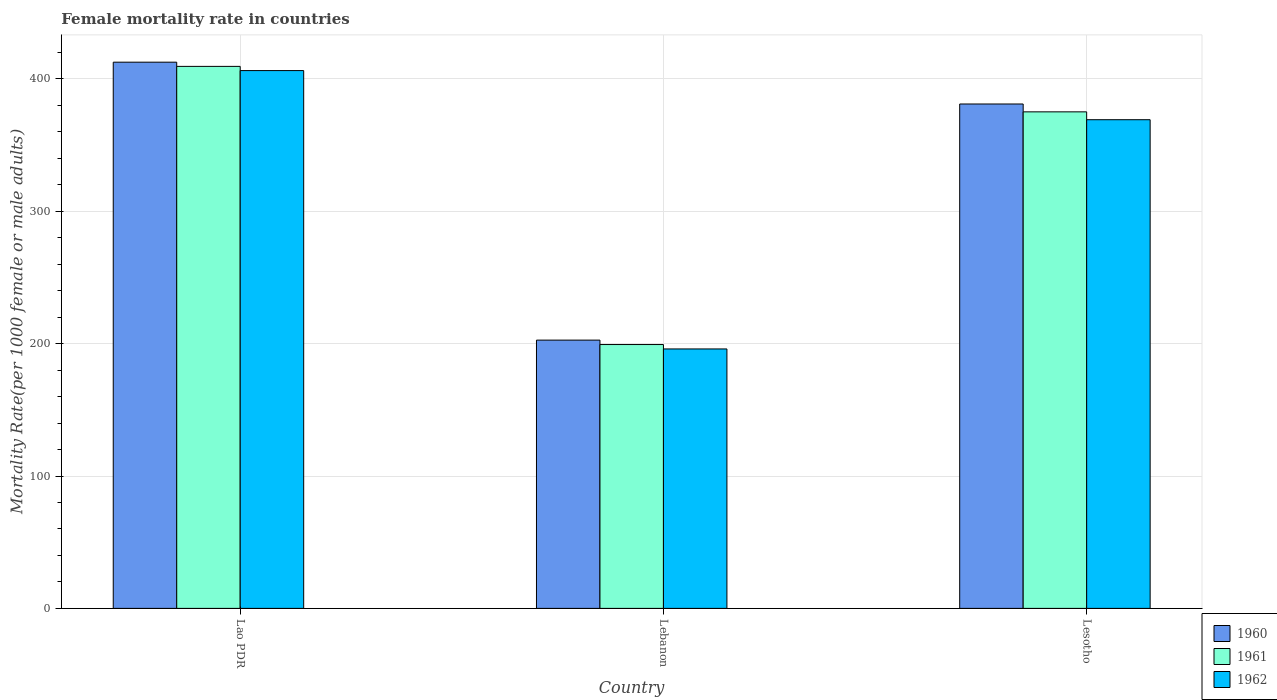How many different coloured bars are there?
Your answer should be compact. 3. How many bars are there on the 1st tick from the left?
Give a very brief answer. 3. What is the label of the 3rd group of bars from the left?
Offer a very short reply. Lesotho. What is the female mortality rate in 1962 in Lesotho?
Give a very brief answer. 369.19. Across all countries, what is the maximum female mortality rate in 1960?
Give a very brief answer. 412.66. Across all countries, what is the minimum female mortality rate in 1962?
Give a very brief answer. 196.01. In which country was the female mortality rate in 1960 maximum?
Make the answer very short. Lao PDR. In which country was the female mortality rate in 1960 minimum?
Provide a succinct answer. Lebanon. What is the total female mortality rate in 1961 in the graph?
Ensure brevity in your answer.  983.96. What is the difference between the female mortality rate in 1961 in Lebanon and that in Lesotho?
Make the answer very short. -175.79. What is the difference between the female mortality rate in 1960 in Lesotho and the female mortality rate in 1961 in Lebanon?
Offer a very short reply. 181.73. What is the average female mortality rate in 1960 per country?
Ensure brevity in your answer.  332.13. What is the difference between the female mortality rate of/in 1962 and female mortality rate of/in 1961 in Lao PDR?
Offer a very short reply. -3.17. In how many countries, is the female mortality rate in 1961 greater than 60?
Offer a terse response. 3. What is the ratio of the female mortality rate in 1962 in Lebanon to that in Lesotho?
Make the answer very short. 0.53. Is the female mortality rate in 1960 in Lao PDR less than that in Lesotho?
Your answer should be very brief. No. What is the difference between the highest and the second highest female mortality rate in 1961?
Make the answer very short. 210.14. What is the difference between the highest and the lowest female mortality rate in 1961?
Provide a short and direct response. 210.14. What does the 2nd bar from the right in Lao PDR represents?
Ensure brevity in your answer.  1961. Is it the case that in every country, the sum of the female mortality rate in 1960 and female mortality rate in 1961 is greater than the female mortality rate in 1962?
Make the answer very short. Yes. How many bars are there?
Your answer should be compact. 9. Are all the bars in the graph horizontal?
Your answer should be compact. No. What is the difference between two consecutive major ticks on the Y-axis?
Keep it short and to the point. 100. Are the values on the major ticks of Y-axis written in scientific E-notation?
Offer a very short reply. No. What is the title of the graph?
Make the answer very short. Female mortality rate in countries. Does "2013" appear as one of the legend labels in the graph?
Your answer should be very brief. No. What is the label or title of the X-axis?
Keep it short and to the point. Country. What is the label or title of the Y-axis?
Your answer should be compact. Mortality Rate(per 1000 female or male adults). What is the Mortality Rate(per 1000 female or male adults) in 1960 in Lao PDR?
Your response must be concise. 412.66. What is the Mortality Rate(per 1000 female or male adults) of 1961 in Lao PDR?
Ensure brevity in your answer.  409.49. What is the Mortality Rate(per 1000 female or male adults) in 1962 in Lao PDR?
Provide a short and direct response. 406.32. What is the Mortality Rate(per 1000 female or male adults) in 1960 in Lebanon?
Your answer should be very brief. 202.68. What is the Mortality Rate(per 1000 female or male adults) of 1961 in Lebanon?
Your answer should be compact. 199.34. What is the Mortality Rate(per 1000 female or male adults) of 1962 in Lebanon?
Ensure brevity in your answer.  196.01. What is the Mortality Rate(per 1000 female or male adults) of 1960 in Lesotho?
Provide a succinct answer. 381.07. What is the Mortality Rate(per 1000 female or male adults) of 1961 in Lesotho?
Ensure brevity in your answer.  375.13. What is the Mortality Rate(per 1000 female or male adults) of 1962 in Lesotho?
Keep it short and to the point. 369.19. Across all countries, what is the maximum Mortality Rate(per 1000 female or male adults) in 1960?
Ensure brevity in your answer.  412.66. Across all countries, what is the maximum Mortality Rate(per 1000 female or male adults) of 1961?
Your answer should be very brief. 409.49. Across all countries, what is the maximum Mortality Rate(per 1000 female or male adults) of 1962?
Your answer should be very brief. 406.32. Across all countries, what is the minimum Mortality Rate(per 1000 female or male adults) of 1960?
Offer a terse response. 202.68. Across all countries, what is the minimum Mortality Rate(per 1000 female or male adults) in 1961?
Provide a succinct answer. 199.34. Across all countries, what is the minimum Mortality Rate(per 1000 female or male adults) of 1962?
Provide a short and direct response. 196.01. What is the total Mortality Rate(per 1000 female or male adults) of 1960 in the graph?
Offer a very short reply. 996.4. What is the total Mortality Rate(per 1000 female or male adults) in 1961 in the graph?
Provide a short and direct response. 983.96. What is the total Mortality Rate(per 1000 female or male adults) in 1962 in the graph?
Give a very brief answer. 971.52. What is the difference between the Mortality Rate(per 1000 female or male adults) of 1960 in Lao PDR and that in Lebanon?
Ensure brevity in your answer.  209.98. What is the difference between the Mortality Rate(per 1000 female or male adults) of 1961 in Lao PDR and that in Lebanon?
Provide a short and direct response. 210.14. What is the difference between the Mortality Rate(per 1000 female or male adults) in 1962 in Lao PDR and that in Lebanon?
Provide a succinct answer. 210.31. What is the difference between the Mortality Rate(per 1000 female or male adults) in 1960 in Lao PDR and that in Lesotho?
Provide a succinct answer. 31.59. What is the difference between the Mortality Rate(per 1000 female or male adults) of 1961 in Lao PDR and that in Lesotho?
Your answer should be compact. 34.36. What is the difference between the Mortality Rate(per 1000 female or male adults) in 1962 in Lao PDR and that in Lesotho?
Provide a succinct answer. 37.12. What is the difference between the Mortality Rate(per 1000 female or male adults) in 1960 in Lebanon and that in Lesotho?
Provide a short and direct response. -178.39. What is the difference between the Mortality Rate(per 1000 female or male adults) in 1961 in Lebanon and that in Lesotho?
Provide a succinct answer. -175.79. What is the difference between the Mortality Rate(per 1000 female or male adults) in 1962 in Lebanon and that in Lesotho?
Provide a short and direct response. -173.19. What is the difference between the Mortality Rate(per 1000 female or male adults) in 1960 in Lao PDR and the Mortality Rate(per 1000 female or male adults) in 1961 in Lebanon?
Ensure brevity in your answer.  213.32. What is the difference between the Mortality Rate(per 1000 female or male adults) of 1960 in Lao PDR and the Mortality Rate(per 1000 female or male adults) of 1962 in Lebanon?
Your response must be concise. 216.65. What is the difference between the Mortality Rate(per 1000 female or male adults) in 1961 in Lao PDR and the Mortality Rate(per 1000 female or male adults) in 1962 in Lebanon?
Keep it short and to the point. 213.48. What is the difference between the Mortality Rate(per 1000 female or male adults) in 1960 in Lao PDR and the Mortality Rate(per 1000 female or male adults) in 1961 in Lesotho?
Provide a short and direct response. 37.53. What is the difference between the Mortality Rate(per 1000 female or male adults) of 1960 in Lao PDR and the Mortality Rate(per 1000 female or male adults) of 1962 in Lesotho?
Your answer should be very brief. 43.46. What is the difference between the Mortality Rate(per 1000 female or male adults) of 1961 in Lao PDR and the Mortality Rate(per 1000 female or male adults) of 1962 in Lesotho?
Your answer should be very brief. 40.29. What is the difference between the Mortality Rate(per 1000 female or male adults) of 1960 in Lebanon and the Mortality Rate(per 1000 female or male adults) of 1961 in Lesotho?
Offer a very short reply. -172.46. What is the difference between the Mortality Rate(per 1000 female or male adults) of 1960 in Lebanon and the Mortality Rate(per 1000 female or male adults) of 1962 in Lesotho?
Your answer should be very brief. -166.52. What is the difference between the Mortality Rate(per 1000 female or male adults) in 1961 in Lebanon and the Mortality Rate(per 1000 female or male adults) in 1962 in Lesotho?
Keep it short and to the point. -169.85. What is the average Mortality Rate(per 1000 female or male adults) of 1960 per country?
Offer a very short reply. 332.13. What is the average Mortality Rate(per 1000 female or male adults) of 1961 per country?
Your answer should be compact. 327.99. What is the average Mortality Rate(per 1000 female or male adults) of 1962 per country?
Your response must be concise. 323.84. What is the difference between the Mortality Rate(per 1000 female or male adults) in 1960 and Mortality Rate(per 1000 female or male adults) in 1961 in Lao PDR?
Make the answer very short. 3.17. What is the difference between the Mortality Rate(per 1000 female or male adults) in 1960 and Mortality Rate(per 1000 female or male adults) in 1962 in Lao PDR?
Provide a short and direct response. 6.34. What is the difference between the Mortality Rate(per 1000 female or male adults) in 1961 and Mortality Rate(per 1000 female or male adults) in 1962 in Lao PDR?
Your answer should be very brief. 3.17. What is the difference between the Mortality Rate(per 1000 female or male adults) in 1960 and Mortality Rate(per 1000 female or male adults) in 1961 in Lebanon?
Provide a short and direct response. 3.33. What is the difference between the Mortality Rate(per 1000 female or male adults) of 1960 and Mortality Rate(per 1000 female or male adults) of 1962 in Lebanon?
Offer a terse response. 6.67. What is the difference between the Mortality Rate(per 1000 female or male adults) of 1961 and Mortality Rate(per 1000 female or male adults) of 1962 in Lebanon?
Your response must be concise. 3.33. What is the difference between the Mortality Rate(per 1000 female or male adults) in 1960 and Mortality Rate(per 1000 female or male adults) in 1961 in Lesotho?
Make the answer very short. 5.94. What is the difference between the Mortality Rate(per 1000 female or male adults) in 1960 and Mortality Rate(per 1000 female or male adults) in 1962 in Lesotho?
Offer a very short reply. 11.87. What is the difference between the Mortality Rate(per 1000 female or male adults) in 1961 and Mortality Rate(per 1000 female or male adults) in 1962 in Lesotho?
Your answer should be compact. 5.94. What is the ratio of the Mortality Rate(per 1000 female or male adults) in 1960 in Lao PDR to that in Lebanon?
Your answer should be compact. 2.04. What is the ratio of the Mortality Rate(per 1000 female or male adults) in 1961 in Lao PDR to that in Lebanon?
Ensure brevity in your answer.  2.05. What is the ratio of the Mortality Rate(per 1000 female or male adults) in 1962 in Lao PDR to that in Lebanon?
Make the answer very short. 2.07. What is the ratio of the Mortality Rate(per 1000 female or male adults) in 1960 in Lao PDR to that in Lesotho?
Your response must be concise. 1.08. What is the ratio of the Mortality Rate(per 1000 female or male adults) in 1961 in Lao PDR to that in Lesotho?
Offer a very short reply. 1.09. What is the ratio of the Mortality Rate(per 1000 female or male adults) in 1962 in Lao PDR to that in Lesotho?
Your response must be concise. 1.1. What is the ratio of the Mortality Rate(per 1000 female or male adults) of 1960 in Lebanon to that in Lesotho?
Your response must be concise. 0.53. What is the ratio of the Mortality Rate(per 1000 female or male adults) in 1961 in Lebanon to that in Lesotho?
Give a very brief answer. 0.53. What is the ratio of the Mortality Rate(per 1000 female or male adults) in 1962 in Lebanon to that in Lesotho?
Your answer should be very brief. 0.53. What is the difference between the highest and the second highest Mortality Rate(per 1000 female or male adults) of 1960?
Offer a very short reply. 31.59. What is the difference between the highest and the second highest Mortality Rate(per 1000 female or male adults) of 1961?
Give a very brief answer. 34.36. What is the difference between the highest and the second highest Mortality Rate(per 1000 female or male adults) in 1962?
Provide a short and direct response. 37.12. What is the difference between the highest and the lowest Mortality Rate(per 1000 female or male adults) of 1960?
Offer a terse response. 209.98. What is the difference between the highest and the lowest Mortality Rate(per 1000 female or male adults) of 1961?
Your answer should be very brief. 210.14. What is the difference between the highest and the lowest Mortality Rate(per 1000 female or male adults) in 1962?
Offer a terse response. 210.31. 